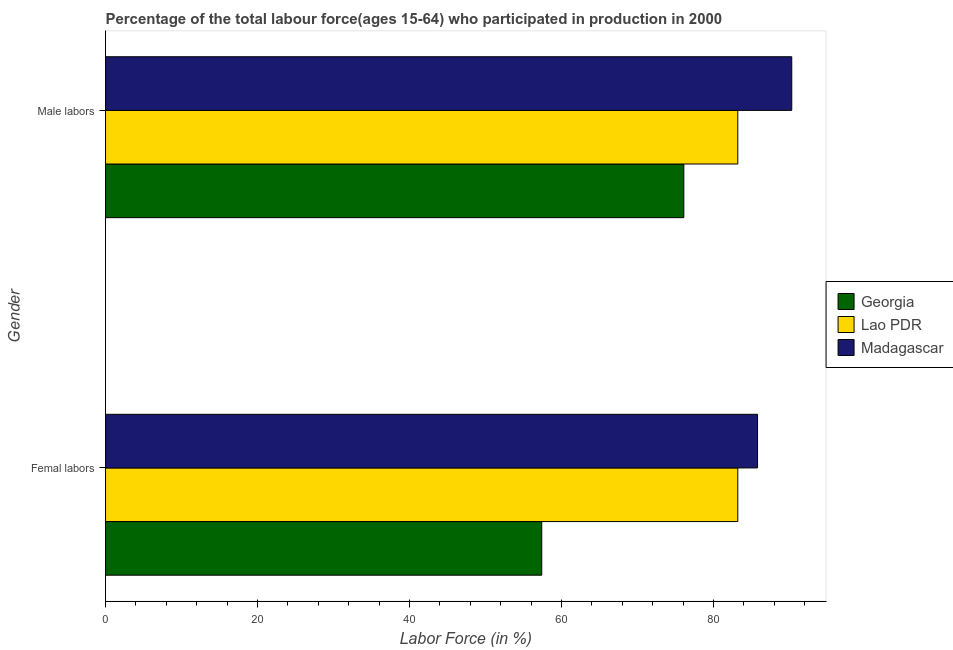How many different coloured bars are there?
Your answer should be very brief. 3. How many groups of bars are there?
Make the answer very short. 2. How many bars are there on the 1st tick from the top?
Provide a succinct answer. 3. What is the label of the 1st group of bars from the top?
Give a very brief answer. Male labors. What is the percentage of male labour force in Madagascar?
Your answer should be very brief. 90.3. Across all countries, what is the maximum percentage of male labour force?
Your response must be concise. 90.3. Across all countries, what is the minimum percentage of male labour force?
Provide a succinct answer. 76.1. In which country was the percentage of female labor force maximum?
Offer a very short reply. Madagascar. In which country was the percentage of female labor force minimum?
Provide a succinct answer. Georgia. What is the total percentage of male labour force in the graph?
Your answer should be compact. 249.6. What is the difference between the percentage of female labor force in Madagascar and that in Georgia?
Make the answer very short. 28.4. What is the difference between the percentage of male labour force in Lao PDR and the percentage of female labor force in Madagascar?
Keep it short and to the point. -2.6. What is the average percentage of female labor force per country?
Provide a succinct answer. 75.47. What is the ratio of the percentage of male labour force in Madagascar to that in Georgia?
Give a very brief answer. 1.19. Is the percentage of female labor force in Lao PDR less than that in Madagascar?
Provide a short and direct response. Yes. In how many countries, is the percentage of female labor force greater than the average percentage of female labor force taken over all countries?
Your answer should be compact. 2. What does the 2nd bar from the top in Male labors represents?
Your response must be concise. Lao PDR. What does the 3rd bar from the bottom in Femal labors represents?
Your response must be concise. Madagascar. How many bars are there?
Give a very brief answer. 6. What is the difference between two consecutive major ticks on the X-axis?
Your response must be concise. 20. Where does the legend appear in the graph?
Your answer should be compact. Center right. How many legend labels are there?
Your answer should be compact. 3. How are the legend labels stacked?
Offer a very short reply. Vertical. What is the title of the graph?
Make the answer very short. Percentage of the total labour force(ages 15-64) who participated in production in 2000. Does "Honduras" appear as one of the legend labels in the graph?
Make the answer very short. No. What is the label or title of the Y-axis?
Provide a short and direct response. Gender. What is the Labor Force (in %) in Georgia in Femal labors?
Keep it short and to the point. 57.4. What is the Labor Force (in %) of Lao PDR in Femal labors?
Your response must be concise. 83.2. What is the Labor Force (in %) of Madagascar in Femal labors?
Offer a very short reply. 85.8. What is the Labor Force (in %) in Georgia in Male labors?
Provide a short and direct response. 76.1. What is the Labor Force (in %) in Lao PDR in Male labors?
Keep it short and to the point. 83.2. What is the Labor Force (in %) in Madagascar in Male labors?
Your answer should be very brief. 90.3. Across all Gender, what is the maximum Labor Force (in %) of Georgia?
Your answer should be compact. 76.1. Across all Gender, what is the maximum Labor Force (in %) of Lao PDR?
Give a very brief answer. 83.2. Across all Gender, what is the maximum Labor Force (in %) in Madagascar?
Your answer should be very brief. 90.3. Across all Gender, what is the minimum Labor Force (in %) of Georgia?
Keep it short and to the point. 57.4. Across all Gender, what is the minimum Labor Force (in %) in Lao PDR?
Provide a short and direct response. 83.2. Across all Gender, what is the minimum Labor Force (in %) in Madagascar?
Your response must be concise. 85.8. What is the total Labor Force (in %) of Georgia in the graph?
Give a very brief answer. 133.5. What is the total Labor Force (in %) in Lao PDR in the graph?
Ensure brevity in your answer.  166.4. What is the total Labor Force (in %) of Madagascar in the graph?
Your answer should be very brief. 176.1. What is the difference between the Labor Force (in %) of Georgia in Femal labors and that in Male labors?
Provide a succinct answer. -18.7. What is the difference between the Labor Force (in %) of Lao PDR in Femal labors and that in Male labors?
Make the answer very short. 0. What is the difference between the Labor Force (in %) of Georgia in Femal labors and the Labor Force (in %) of Lao PDR in Male labors?
Make the answer very short. -25.8. What is the difference between the Labor Force (in %) in Georgia in Femal labors and the Labor Force (in %) in Madagascar in Male labors?
Ensure brevity in your answer.  -32.9. What is the difference between the Labor Force (in %) of Lao PDR in Femal labors and the Labor Force (in %) of Madagascar in Male labors?
Offer a terse response. -7.1. What is the average Labor Force (in %) in Georgia per Gender?
Your response must be concise. 66.75. What is the average Labor Force (in %) in Lao PDR per Gender?
Keep it short and to the point. 83.2. What is the average Labor Force (in %) in Madagascar per Gender?
Your answer should be very brief. 88.05. What is the difference between the Labor Force (in %) of Georgia and Labor Force (in %) of Lao PDR in Femal labors?
Keep it short and to the point. -25.8. What is the difference between the Labor Force (in %) of Georgia and Labor Force (in %) of Madagascar in Femal labors?
Keep it short and to the point. -28.4. What is the ratio of the Labor Force (in %) of Georgia in Femal labors to that in Male labors?
Ensure brevity in your answer.  0.75. What is the ratio of the Labor Force (in %) in Madagascar in Femal labors to that in Male labors?
Offer a terse response. 0.95. What is the difference between the highest and the second highest Labor Force (in %) of Georgia?
Provide a succinct answer. 18.7. What is the difference between the highest and the second highest Labor Force (in %) in Lao PDR?
Keep it short and to the point. 0. What is the difference between the highest and the lowest Labor Force (in %) of Georgia?
Your answer should be compact. 18.7. What is the difference between the highest and the lowest Labor Force (in %) in Lao PDR?
Your response must be concise. 0. What is the difference between the highest and the lowest Labor Force (in %) of Madagascar?
Give a very brief answer. 4.5. 